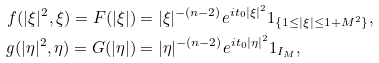Convert formula to latex. <formula><loc_0><loc_0><loc_500><loc_500>f ( | \xi | ^ { 2 } , \xi ) = F ( | \xi | ) & = | \xi | ^ { - ( n - 2 ) } e ^ { i t _ { 0 } | \xi | ^ { 2 } } 1 _ { \{ 1 \leq | \xi | \leq 1 + M ^ { 2 } \} } , \\ g ( | \eta | ^ { 2 } , \eta ) = G ( | \eta | ) & = | \eta | ^ { - ( n - 2 ) } e ^ { i t _ { 0 } | \eta | ^ { 2 } } 1 _ { I _ { M } } ,</formula> 